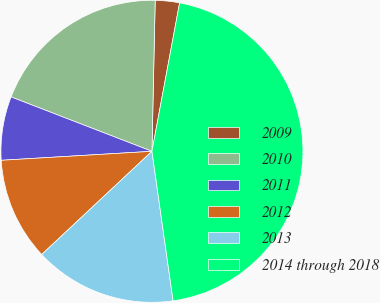Convert chart. <chart><loc_0><loc_0><loc_500><loc_500><pie_chart><fcel>2009<fcel>2010<fcel>2011<fcel>2012<fcel>2013<fcel>2014 through 2018<nl><fcel>2.59%<fcel>19.48%<fcel>6.81%<fcel>11.03%<fcel>15.26%<fcel>44.83%<nl></chart> 